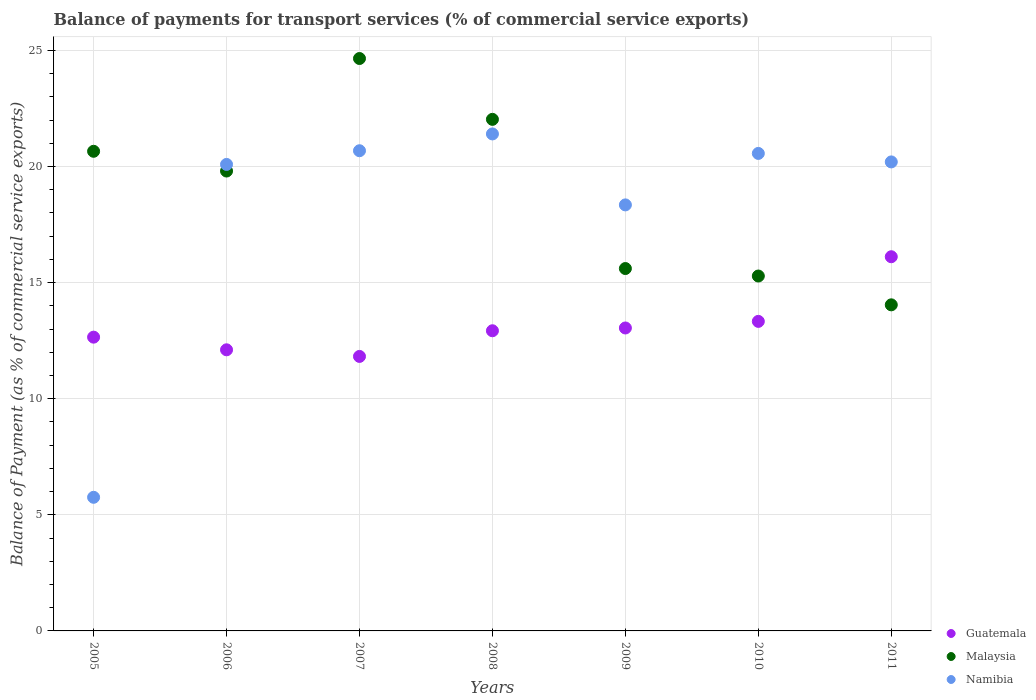Is the number of dotlines equal to the number of legend labels?
Your response must be concise. Yes. What is the balance of payments for transport services in Guatemala in 2011?
Provide a short and direct response. 16.11. Across all years, what is the maximum balance of payments for transport services in Guatemala?
Keep it short and to the point. 16.11. Across all years, what is the minimum balance of payments for transport services in Guatemala?
Give a very brief answer. 11.82. In which year was the balance of payments for transport services in Malaysia maximum?
Your answer should be very brief. 2007. What is the total balance of payments for transport services in Namibia in the graph?
Provide a short and direct response. 127.02. What is the difference between the balance of payments for transport services in Namibia in 2008 and that in 2010?
Your answer should be compact. 0.84. What is the difference between the balance of payments for transport services in Guatemala in 2006 and the balance of payments for transport services in Malaysia in 2005?
Offer a terse response. -8.55. What is the average balance of payments for transport services in Namibia per year?
Your response must be concise. 18.15. In the year 2011, what is the difference between the balance of payments for transport services in Malaysia and balance of payments for transport services in Namibia?
Your response must be concise. -6.15. What is the ratio of the balance of payments for transport services in Guatemala in 2005 to that in 2009?
Your answer should be very brief. 0.97. Is the balance of payments for transport services in Guatemala in 2006 less than that in 2009?
Give a very brief answer. Yes. Is the difference between the balance of payments for transport services in Malaysia in 2006 and 2011 greater than the difference between the balance of payments for transport services in Namibia in 2006 and 2011?
Ensure brevity in your answer.  Yes. What is the difference between the highest and the second highest balance of payments for transport services in Malaysia?
Make the answer very short. 2.62. What is the difference between the highest and the lowest balance of payments for transport services in Namibia?
Give a very brief answer. 15.65. In how many years, is the balance of payments for transport services in Guatemala greater than the average balance of payments for transport services in Guatemala taken over all years?
Your answer should be compact. 2. Is the sum of the balance of payments for transport services in Guatemala in 2007 and 2008 greater than the maximum balance of payments for transport services in Malaysia across all years?
Your answer should be very brief. Yes. Does the balance of payments for transport services in Guatemala monotonically increase over the years?
Make the answer very short. No. Is the balance of payments for transport services in Guatemala strictly less than the balance of payments for transport services in Namibia over the years?
Provide a succinct answer. No. How many dotlines are there?
Offer a terse response. 3. What is the difference between two consecutive major ticks on the Y-axis?
Make the answer very short. 5. Are the values on the major ticks of Y-axis written in scientific E-notation?
Make the answer very short. No. Does the graph contain any zero values?
Offer a terse response. No. How many legend labels are there?
Give a very brief answer. 3. What is the title of the graph?
Your answer should be very brief. Balance of payments for transport services (% of commercial service exports). What is the label or title of the X-axis?
Provide a succinct answer. Years. What is the label or title of the Y-axis?
Your answer should be compact. Balance of Payment (as % of commercial service exports). What is the Balance of Payment (as % of commercial service exports) in Guatemala in 2005?
Your response must be concise. 12.65. What is the Balance of Payment (as % of commercial service exports) of Malaysia in 2005?
Offer a very short reply. 20.65. What is the Balance of Payment (as % of commercial service exports) of Namibia in 2005?
Provide a short and direct response. 5.75. What is the Balance of Payment (as % of commercial service exports) in Guatemala in 2006?
Make the answer very short. 12.1. What is the Balance of Payment (as % of commercial service exports) in Malaysia in 2006?
Ensure brevity in your answer.  19.8. What is the Balance of Payment (as % of commercial service exports) of Namibia in 2006?
Offer a terse response. 20.09. What is the Balance of Payment (as % of commercial service exports) of Guatemala in 2007?
Provide a short and direct response. 11.82. What is the Balance of Payment (as % of commercial service exports) of Malaysia in 2007?
Provide a short and direct response. 24.65. What is the Balance of Payment (as % of commercial service exports) of Namibia in 2007?
Offer a terse response. 20.68. What is the Balance of Payment (as % of commercial service exports) in Guatemala in 2008?
Ensure brevity in your answer.  12.92. What is the Balance of Payment (as % of commercial service exports) of Malaysia in 2008?
Ensure brevity in your answer.  22.03. What is the Balance of Payment (as % of commercial service exports) of Namibia in 2008?
Make the answer very short. 21.4. What is the Balance of Payment (as % of commercial service exports) in Guatemala in 2009?
Offer a very short reply. 13.04. What is the Balance of Payment (as % of commercial service exports) of Malaysia in 2009?
Give a very brief answer. 15.6. What is the Balance of Payment (as % of commercial service exports) in Namibia in 2009?
Give a very brief answer. 18.34. What is the Balance of Payment (as % of commercial service exports) in Guatemala in 2010?
Offer a terse response. 13.33. What is the Balance of Payment (as % of commercial service exports) of Malaysia in 2010?
Provide a succinct answer. 15.28. What is the Balance of Payment (as % of commercial service exports) of Namibia in 2010?
Keep it short and to the point. 20.56. What is the Balance of Payment (as % of commercial service exports) of Guatemala in 2011?
Offer a terse response. 16.11. What is the Balance of Payment (as % of commercial service exports) in Malaysia in 2011?
Keep it short and to the point. 14.04. What is the Balance of Payment (as % of commercial service exports) of Namibia in 2011?
Your answer should be compact. 20.2. Across all years, what is the maximum Balance of Payment (as % of commercial service exports) of Guatemala?
Offer a terse response. 16.11. Across all years, what is the maximum Balance of Payment (as % of commercial service exports) of Malaysia?
Your response must be concise. 24.65. Across all years, what is the maximum Balance of Payment (as % of commercial service exports) of Namibia?
Provide a succinct answer. 21.4. Across all years, what is the minimum Balance of Payment (as % of commercial service exports) in Guatemala?
Your answer should be very brief. 11.82. Across all years, what is the minimum Balance of Payment (as % of commercial service exports) of Malaysia?
Offer a very short reply. 14.04. Across all years, what is the minimum Balance of Payment (as % of commercial service exports) in Namibia?
Provide a short and direct response. 5.75. What is the total Balance of Payment (as % of commercial service exports) of Guatemala in the graph?
Keep it short and to the point. 91.98. What is the total Balance of Payment (as % of commercial service exports) in Malaysia in the graph?
Ensure brevity in your answer.  132.06. What is the total Balance of Payment (as % of commercial service exports) in Namibia in the graph?
Provide a short and direct response. 127.02. What is the difference between the Balance of Payment (as % of commercial service exports) in Guatemala in 2005 and that in 2006?
Your answer should be very brief. 0.54. What is the difference between the Balance of Payment (as % of commercial service exports) of Malaysia in 2005 and that in 2006?
Give a very brief answer. 0.85. What is the difference between the Balance of Payment (as % of commercial service exports) in Namibia in 2005 and that in 2006?
Ensure brevity in your answer.  -14.33. What is the difference between the Balance of Payment (as % of commercial service exports) in Guatemala in 2005 and that in 2007?
Your response must be concise. 0.83. What is the difference between the Balance of Payment (as % of commercial service exports) of Malaysia in 2005 and that in 2007?
Provide a short and direct response. -4. What is the difference between the Balance of Payment (as % of commercial service exports) in Namibia in 2005 and that in 2007?
Make the answer very short. -14.92. What is the difference between the Balance of Payment (as % of commercial service exports) in Guatemala in 2005 and that in 2008?
Your answer should be compact. -0.28. What is the difference between the Balance of Payment (as % of commercial service exports) of Malaysia in 2005 and that in 2008?
Ensure brevity in your answer.  -1.38. What is the difference between the Balance of Payment (as % of commercial service exports) in Namibia in 2005 and that in 2008?
Your answer should be compact. -15.65. What is the difference between the Balance of Payment (as % of commercial service exports) in Guatemala in 2005 and that in 2009?
Offer a very short reply. -0.4. What is the difference between the Balance of Payment (as % of commercial service exports) of Malaysia in 2005 and that in 2009?
Make the answer very short. 5.05. What is the difference between the Balance of Payment (as % of commercial service exports) of Namibia in 2005 and that in 2009?
Offer a terse response. -12.59. What is the difference between the Balance of Payment (as % of commercial service exports) in Guatemala in 2005 and that in 2010?
Your answer should be compact. -0.68. What is the difference between the Balance of Payment (as % of commercial service exports) of Malaysia in 2005 and that in 2010?
Give a very brief answer. 5.37. What is the difference between the Balance of Payment (as % of commercial service exports) in Namibia in 2005 and that in 2010?
Your response must be concise. -14.81. What is the difference between the Balance of Payment (as % of commercial service exports) of Guatemala in 2005 and that in 2011?
Keep it short and to the point. -3.46. What is the difference between the Balance of Payment (as % of commercial service exports) of Malaysia in 2005 and that in 2011?
Provide a short and direct response. 6.61. What is the difference between the Balance of Payment (as % of commercial service exports) in Namibia in 2005 and that in 2011?
Offer a very short reply. -14.44. What is the difference between the Balance of Payment (as % of commercial service exports) in Guatemala in 2006 and that in 2007?
Provide a succinct answer. 0.28. What is the difference between the Balance of Payment (as % of commercial service exports) of Malaysia in 2006 and that in 2007?
Keep it short and to the point. -4.85. What is the difference between the Balance of Payment (as % of commercial service exports) of Namibia in 2006 and that in 2007?
Your answer should be compact. -0.59. What is the difference between the Balance of Payment (as % of commercial service exports) of Guatemala in 2006 and that in 2008?
Provide a short and direct response. -0.82. What is the difference between the Balance of Payment (as % of commercial service exports) in Malaysia in 2006 and that in 2008?
Offer a very short reply. -2.23. What is the difference between the Balance of Payment (as % of commercial service exports) in Namibia in 2006 and that in 2008?
Your answer should be very brief. -1.31. What is the difference between the Balance of Payment (as % of commercial service exports) of Guatemala in 2006 and that in 2009?
Your answer should be very brief. -0.94. What is the difference between the Balance of Payment (as % of commercial service exports) in Malaysia in 2006 and that in 2009?
Offer a terse response. 4.2. What is the difference between the Balance of Payment (as % of commercial service exports) in Namibia in 2006 and that in 2009?
Provide a short and direct response. 1.74. What is the difference between the Balance of Payment (as % of commercial service exports) of Guatemala in 2006 and that in 2010?
Provide a succinct answer. -1.22. What is the difference between the Balance of Payment (as % of commercial service exports) of Malaysia in 2006 and that in 2010?
Offer a terse response. 4.52. What is the difference between the Balance of Payment (as % of commercial service exports) of Namibia in 2006 and that in 2010?
Ensure brevity in your answer.  -0.47. What is the difference between the Balance of Payment (as % of commercial service exports) in Guatemala in 2006 and that in 2011?
Your response must be concise. -4.01. What is the difference between the Balance of Payment (as % of commercial service exports) of Malaysia in 2006 and that in 2011?
Your answer should be compact. 5.76. What is the difference between the Balance of Payment (as % of commercial service exports) of Namibia in 2006 and that in 2011?
Your answer should be very brief. -0.11. What is the difference between the Balance of Payment (as % of commercial service exports) of Guatemala in 2007 and that in 2008?
Ensure brevity in your answer.  -1.1. What is the difference between the Balance of Payment (as % of commercial service exports) of Malaysia in 2007 and that in 2008?
Provide a succinct answer. 2.62. What is the difference between the Balance of Payment (as % of commercial service exports) of Namibia in 2007 and that in 2008?
Ensure brevity in your answer.  -0.72. What is the difference between the Balance of Payment (as % of commercial service exports) of Guatemala in 2007 and that in 2009?
Ensure brevity in your answer.  -1.22. What is the difference between the Balance of Payment (as % of commercial service exports) in Malaysia in 2007 and that in 2009?
Your answer should be compact. 9.04. What is the difference between the Balance of Payment (as % of commercial service exports) of Namibia in 2007 and that in 2009?
Provide a short and direct response. 2.33. What is the difference between the Balance of Payment (as % of commercial service exports) of Guatemala in 2007 and that in 2010?
Offer a very short reply. -1.51. What is the difference between the Balance of Payment (as % of commercial service exports) of Malaysia in 2007 and that in 2010?
Your answer should be compact. 9.37. What is the difference between the Balance of Payment (as % of commercial service exports) of Namibia in 2007 and that in 2010?
Ensure brevity in your answer.  0.12. What is the difference between the Balance of Payment (as % of commercial service exports) of Guatemala in 2007 and that in 2011?
Give a very brief answer. -4.29. What is the difference between the Balance of Payment (as % of commercial service exports) in Malaysia in 2007 and that in 2011?
Provide a short and direct response. 10.61. What is the difference between the Balance of Payment (as % of commercial service exports) in Namibia in 2007 and that in 2011?
Provide a succinct answer. 0.48. What is the difference between the Balance of Payment (as % of commercial service exports) of Guatemala in 2008 and that in 2009?
Offer a terse response. -0.12. What is the difference between the Balance of Payment (as % of commercial service exports) of Malaysia in 2008 and that in 2009?
Ensure brevity in your answer.  6.42. What is the difference between the Balance of Payment (as % of commercial service exports) in Namibia in 2008 and that in 2009?
Your response must be concise. 3.06. What is the difference between the Balance of Payment (as % of commercial service exports) in Guatemala in 2008 and that in 2010?
Give a very brief answer. -0.4. What is the difference between the Balance of Payment (as % of commercial service exports) of Malaysia in 2008 and that in 2010?
Offer a terse response. 6.75. What is the difference between the Balance of Payment (as % of commercial service exports) of Namibia in 2008 and that in 2010?
Keep it short and to the point. 0.84. What is the difference between the Balance of Payment (as % of commercial service exports) in Guatemala in 2008 and that in 2011?
Keep it short and to the point. -3.19. What is the difference between the Balance of Payment (as % of commercial service exports) in Malaysia in 2008 and that in 2011?
Your answer should be compact. 7.99. What is the difference between the Balance of Payment (as % of commercial service exports) of Namibia in 2008 and that in 2011?
Provide a succinct answer. 1.2. What is the difference between the Balance of Payment (as % of commercial service exports) in Guatemala in 2009 and that in 2010?
Provide a short and direct response. -0.28. What is the difference between the Balance of Payment (as % of commercial service exports) of Malaysia in 2009 and that in 2010?
Your answer should be very brief. 0.32. What is the difference between the Balance of Payment (as % of commercial service exports) of Namibia in 2009 and that in 2010?
Your answer should be compact. -2.22. What is the difference between the Balance of Payment (as % of commercial service exports) in Guatemala in 2009 and that in 2011?
Give a very brief answer. -3.07. What is the difference between the Balance of Payment (as % of commercial service exports) in Malaysia in 2009 and that in 2011?
Your answer should be very brief. 1.56. What is the difference between the Balance of Payment (as % of commercial service exports) in Namibia in 2009 and that in 2011?
Offer a very short reply. -1.85. What is the difference between the Balance of Payment (as % of commercial service exports) of Guatemala in 2010 and that in 2011?
Offer a very short reply. -2.78. What is the difference between the Balance of Payment (as % of commercial service exports) of Malaysia in 2010 and that in 2011?
Your response must be concise. 1.24. What is the difference between the Balance of Payment (as % of commercial service exports) in Namibia in 2010 and that in 2011?
Provide a short and direct response. 0.37. What is the difference between the Balance of Payment (as % of commercial service exports) of Guatemala in 2005 and the Balance of Payment (as % of commercial service exports) of Malaysia in 2006?
Provide a short and direct response. -7.15. What is the difference between the Balance of Payment (as % of commercial service exports) in Guatemala in 2005 and the Balance of Payment (as % of commercial service exports) in Namibia in 2006?
Your response must be concise. -7.44. What is the difference between the Balance of Payment (as % of commercial service exports) of Malaysia in 2005 and the Balance of Payment (as % of commercial service exports) of Namibia in 2006?
Offer a very short reply. 0.57. What is the difference between the Balance of Payment (as % of commercial service exports) of Guatemala in 2005 and the Balance of Payment (as % of commercial service exports) of Malaysia in 2007?
Your response must be concise. -12. What is the difference between the Balance of Payment (as % of commercial service exports) in Guatemala in 2005 and the Balance of Payment (as % of commercial service exports) in Namibia in 2007?
Provide a succinct answer. -8.03. What is the difference between the Balance of Payment (as % of commercial service exports) in Malaysia in 2005 and the Balance of Payment (as % of commercial service exports) in Namibia in 2007?
Offer a terse response. -0.02. What is the difference between the Balance of Payment (as % of commercial service exports) of Guatemala in 2005 and the Balance of Payment (as % of commercial service exports) of Malaysia in 2008?
Provide a succinct answer. -9.38. What is the difference between the Balance of Payment (as % of commercial service exports) of Guatemala in 2005 and the Balance of Payment (as % of commercial service exports) of Namibia in 2008?
Provide a succinct answer. -8.75. What is the difference between the Balance of Payment (as % of commercial service exports) in Malaysia in 2005 and the Balance of Payment (as % of commercial service exports) in Namibia in 2008?
Keep it short and to the point. -0.75. What is the difference between the Balance of Payment (as % of commercial service exports) of Guatemala in 2005 and the Balance of Payment (as % of commercial service exports) of Malaysia in 2009?
Ensure brevity in your answer.  -2.95. What is the difference between the Balance of Payment (as % of commercial service exports) of Guatemala in 2005 and the Balance of Payment (as % of commercial service exports) of Namibia in 2009?
Give a very brief answer. -5.7. What is the difference between the Balance of Payment (as % of commercial service exports) of Malaysia in 2005 and the Balance of Payment (as % of commercial service exports) of Namibia in 2009?
Keep it short and to the point. 2.31. What is the difference between the Balance of Payment (as % of commercial service exports) of Guatemala in 2005 and the Balance of Payment (as % of commercial service exports) of Malaysia in 2010?
Offer a very short reply. -2.63. What is the difference between the Balance of Payment (as % of commercial service exports) of Guatemala in 2005 and the Balance of Payment (as % of commercial service exports) of Namibia in 2010?
Ensure brevity in your answer.  -7.91. What is the difference between the Balance of Payment (as % of commercial service exports) of Malaysia in 2005 and the Balance of Payment (as % of commercial service exports) of Namibia in 2010?
Keep it short and to the point. 0.09. What is the difference between the Balance of Payment (as % of commercial service exports) in Guatemala in 2005 and the Balance of Payment (as % of commercial service exports) in Malaysia in 2011?
Provide a succinct answer. -1.39. What is the difference between the Balance of Payment (as % of commercial service exports) of Guatemala in 2005 and the Balance of Payment (as % of commercial service exports) of Namibia in 2011?
Make the answer very short. -7.55. What is the difference between the Balance of Payment (as % of commercial service exports) of Malaysia in 2005 and the Balance of Payment (as % of commercial service exports) of Namibia in 2011?
Your answer should be compact. 0.46. What is the difference between the Balance of Payment (as % of commercial service exports) of Guatemala in 2006 and the Balance of Payment (as % of commercial service exports) of Malaysia in 2007?
Your response must be concise. -12.54. What is the difference between the Balance of Payment (as % of commercial service exports) of Guatemala in 2006 and the Balance of Payment (as % of commercial service exports) of Namibia in 2007?
Ensure brevity in your answer.  -8.57. What is the difference between the Balance of Payment (as % of commercial service exports) in Malaysia in 2006 and the Balance of Payment (as % of commercial service exports) in Namibia in 2007?
Your response must be concise. -0.87. What is the difference between the Balance of Payment (as % of commercial service exports) in Guatemala in 2006 and the Balance of Payment (as % of commercial service exports) in Malaysia in 2008?
Your answer should be compact. -9.92. What is the difference between the Balance of Payment (as % of commercial service exports) in Guatemala in 2006 and the Balance of Payment (as % of commercial service exports) in Namibia in 2008?
Provide a succinct answer. -9.3. What is the difference between the Balance of Payment (as % of commercial service exports) of Malaysia in 2006 and the Balance of Payment (as % of commercial service exports) of Namibia in 2008?
Give a very brief answer. -1.6. What is the difference between the Balance of Payment (as % of commercial service exports) of Guatemala in 2006 and the Balance of Payment (as % of commercial service exports) of Malaysia in 2009?
Provide a short and direct response. -3.5. What is the difference between the Balance of Payment (as % of commercial service exports) of Guatemala in 2006 and the Balance of Payment (as % of commercial service exports) of Namibia in 2009?
Provide a succinct answer. -6.24. What is the difference between the Balance of Payment (as % of commercial service exports) of Malaysia in 2006 and the Balance of Payment (as % of commercial service exports) of Namibia in 2009?
Your answer should be very brief. 1.46. What is the difference between the Balance of Payment (as % of commercial service exports) in Guatemala in 2006 and the Balance of Payment (as % of commercial service exports) in Malaysia in 2010?
Offer a terse response. -3.18. What is the difference between the Balance of Payment (as % of commercial service exports) in Guatemala in 2006 and the Balance of Payment (as % of commercial service exports) in Namibia in 2010?
Your response must be concise. -8.46. What is the difference between the Balance of Payment (as % of commercial service exports) of Malaysia in 2006 and the Balance of Payment (as % of commercial service exports) of Namibia in 2010?
Provide a short and direct response. -0.76. What is the difference between the Balance of Payment (as % of commercial service exports) of Guatemala in 2006 and the Balance of Payment (as % of commercial service exports) of Malaysia in 2011?
Your answer should be compact. -1.94. What is the difference between the Balance of Payment (as % of commercial service exports) in Guatemala in 2006 and the Balance of Payment (as % of commercial service exports) in Namibia in 2011?
Give a very brief answer. -8.09. What is the difference between the Balance of Payment (as % of commercial service exports) of Malaysia in 2006 and the Balance of Payment (as % of commercial service exports) of Namibia in 2011?
Provide a succinct answer. -0.39. What is the difference between the Balance of Payment (as % of commercial service exports) in Guatemala in 2007 and the Balance of Payment (as % of commercial service exports) in Malaysia in 2008?
Ensure brevity in your answer.  -10.21. What is the difference between the Balance of Payment (as % of commercial service exports) in Guatemala in 2007 and the Balance of Payment (as % of commercial service exports) in Namibia in 2008?
Your response must be concise. -9.58. What is the difference between the Balance of Payment (as % of commercial service exports) of Malaysia in 2007 and the Balance of Payment (as % of commercial service exports) of Namibia in 2008?
Offer a very short reply. 3.25. What is the difference between the Balance of Payment (as % of commercial service exports) of Guatemala in 2007 and the Balance of Payment (as % of commercial service exports) of Malaysia in 2009?
Your answer should be very brief. -3.78. What is the difference between the Balance of Payment (as % of commercial service exports) of Guatemala in 2007 and the Balance of Payment (as % of commercial service exports) of Namibia in 2009?
Ensure brevity in your answer.  -6.52. What is the difference between the Balance of Payment (as % of commercial service exports) of Malaysia in 2007 and the Balance of Payment (as % of commercial service exports) of Namibia in 2009?
Provide a short and direct response. 6.3. What is the difference between the Balance of Payment (as % of commercial service exports) of Guatemala in 2007 and the Balance of Payment (as % of commercial service exports) of Malaysia in 2010?
Give a very brief answer. -3.46. What is the difference between the Balance of Payment (as % of commercial service exports) in Guatemala in 2007 and the Balance of Payment (as % of commercial service exports) in Namibia in 2010?
Offer a very short reply. -8.74. What is the difference between the Balance of Payment (as % of commercial service exports) of Malaysia in 2007 and the Balance of Payment (as % of commercial service exports) of Namibia in 2010?
Your answer should be compact. 4.09. What is the difference between the Balance of Payment (as % of commercial service exports) in Guatemala in 2007 and the Balance of Payment (as % of commercial service exports) in Malaysia in 2011?
Make the answer very short. -2.22. What is the difference between the Balance of Payment (as % of commercial service exports) in Guatemala in 2007 and the Balance of Payment (as % of commercial service exports) in Namibia in 2011?
Your answer should be compact. -8.38. What is the difference between the Balance of Payment (as % of commercial service exports) of Malaysia in 2007 and the Balance of Payment (as % of commercial service exports) of Namibia in 2011?
Your response must be concise. 4.45. What is the difference between the Balance of Payment (as % of commercial service exports) in Guatemala in 2008 and the Balance of Payment (as % of commercial service exports) in Malaysia in 2009?
Ensure brevity in your answer.  -2.68. What is the difference between the Balance of Payment (as % of commercial service exports) in Guatemala in 2008 and the Balance of Payment (as % of commercial service exports) in Namibia in 2009?
Keep it short and to the point. -5.42. What is the difference between the Balance of Payment (as % of commercial service exports) in Malaysia in 2008 and the Balance of Payment (as % of commercial service exports) in Namibia in 2009?
Provide a short and direct response. 3.68. What is the difference between the Balance of Payment (as % of commercial service exports) of Guatemala in 2008 and the Balance of Payment (as % of commercial service exports) of Malaysia in 2010?
Offer a very short reply. -2.36. What is the difference between the Balance of Payment (as % of commercial service exports) of Guatemala in 2008 and the Balance of Payment (as % of commercial service exports) of Namibia in 2010?
Your answer should be compact. -7.64. What is the difference between the Balance of Payment (as % of commercial service exports) of Malaysia in 2008 and the Balance of Payment (as % of commercial service exports) of Namibia in 2010?
Offer a very short reply. 1.47. What is the difference between the Balance of Payment (as % of commercial service exports) of Guatemala in 2008 and the Balance of Payment (as % of commercial service exports) of Malaysia in 2011?
Your response must be concise. -1.12. What is the difference between the Balance of Payment (as % of commercial service exports) in Guatemala in 2008 and the Balance of Payment (as % of commercial service exports) in Namibia in 2011?
Provide a short and direct response. -7.27. What is the difference between the Balance of Payment (as % of commercial service exports) of Malaysia in 2008 and the Balance of Payment (as % of commercial service exports) of Namibia in 2011?
Offer a very short reply. 1.83. What is the difference between the Balance of Payment (as % of commercial service exports) in Guatemala in 2009 and the Balance of Payment (as % of commercial service exports) in Malaysia in 2010?
Provide a short and direct response. -2.24. What is the difference between the Balance of Payment (as % of commercial service exports) of Guatemala in 2009 and the Balance of Payment (as % of commercial service exports) of Namibia in 2010?
Offer a terse response. -7.52. What is the difference between the Balance of Payment (as % of commercial service exports) in Malaysia in 2009 and the Balance of Payment (as % of commercial service exports) in Namibia in 2010?
Provide a succinct answer. -4.96. What is the difference between the Balance of Payment (as % of commercial service exports) of Guatemala in 2009 and the Balance of Payment (as % of commercial service exports) of Malaysia in 2011?
Keep it short and to the point. -1. What is the difference between the Balance of Payment (as % of commercial service exports) of Guatemala in 2009 and the Balance of Payment (as % of commercial service exports) of Namibia in 2011?
Keep it short and to the point. -7.15. What is the difference between the Balance of Payment (as % of commercial service exports) in Malaysia in 2009 and the Balance of Payment (as % of commercial service exports) in Namibia in 2011?
Provide a succinct answer. -4.59. What is the difference between the Balance of Payment (as % of commercial service exports) of Guatemala in 2010 and the Balance of Payment (as % of commercial service exports) of Malaysia in 2011?
Give a very brief answer. -0.71. What is the difference between the Balance of Payment (as % of commercial service exports) in Guatemala in 2010 and the Balance of Payment (as % of commercial service exports) in Namibia in 2011?
Keep it short and to the point. -6.87. What is the difference between the Balance of Payment (as % of commercial service exports) in Malaysia in 2010 and the Balance of Payment (as % of commercial service exports) in Namibia in 2011?
Offer a very short reply. -4.91. What is the average Balance of Payment (as % of commercial service exports) of Guatemala per year?
Provide a succinct answer. 13.14. What is the average Balance of Payment (as % of commercial service exports) of Malaysia per year?
Your answer should be very brief. 18.87. What is the average Balance of Payment (as % of commercial service exports) of Namibia per year?
Your answer should be very brief. 18.15. In the year 2005, what is the difference between the Balance of Payment (as % of commercial service exports) in Guatemala and Balance of Payment (as % of commercial service exports) in Malaysia?
Offer a very short reply. -8. In the year 2005, what is the difference between the Balance of Payment (as % of commercial service exports) in Guatemala and Balance of Payment (as % of commercial service exports) in Namibia?
Your answer should be very brief. 6.9. In the year 2005, what is the difference between the Balance of Payment (as % of commercial service exports) in Malaysia and Balance of Payment (as % of commercial service exports) in Namibia?
Offer a terse response. 14.9. In the year 2006, what is the difference between the Balance of Payment (as % of commercial service exports) of Guatemala and Balance of Payment (as % of commercial service exports) of Malaysia?
Offer a very short reply. -7.7. In the year 2006, what is the difference between the Balance of Payment (as % of commercial service exports) of Guatemala and Balance of Payment (as % of commercial service exports) of Namibia?
Make the answer very short. -7.98. In the year 2006, what is the difference between the Balance of Payment (as % of commercial service exports) in Malaysia and Balance of Payment (as % of commercial service exports) in Namibia?
Provide a succinct answer. -0.28. In the year 2007, what is the difference between the Balance of Payment (as % of commercial service exports) in Guatemala and Balance of Payment (as % of commercial service exports) in Malaysia?
Keep it short and to the point. -12.83. In the year 2007, what is the difference between the Balance of Payment (as % of commercial service exports) in Guatemala and Balance of Payment (as % of commercial service exports) in Namibia?
Give a very brief answer. -8.86. In the year 2007, what is the difference between the Balance of Payment (as % of commercial service exports) in Malaysia and Balance of Payment (as % of commercial service exports) in Namibia?
Provide a short and direct response. 3.97. In the year 2008, what is the difference between the Balance of Payment (as % of commercial service exports) in Guatemala and Balance of Payment (as % of commercial service exports) in Malaysia?
Keep it short and to the point. -9.1. In the year 2008, what is the difference between the Balance of Payment (as % of commercial service exports) in Guatemala and Balance of Payment (as % of commercial service exports) in Namibia?
Your response must be concise. -8.48. In the year 2008, what is the difference between the Balance of Payment (as % of commercial service exports) in Malaysia and Balance of Payment (as % of commercial service exports) in Namibia?
Keep it short and to the point. 0.63. In the year 2009, what is the difference between the Balance of Payment (as % of commercial service exports) of Guatemala and Balance of Payment (as % of commercial service exports) of Malaysia?
Ensure brevity in your answer.  -2.56. In the year 2009, what is the difference between the Balance of Payment (as % of commercial service exports) of Guatemala and Balance of Payment (as % of commercial service exports) of Namibia?
Your response must be concise. -5.3. In the year 2009, what is the difference between the Balance of Payment (as % of commercial service exports) of Malaysia and Balance of Payment (as % of commercial service exports) of Namibia?
Give a very brief answer. -2.74. In the year 2010, what is the difference between the Balance of Payment (as % of commercial service exports) of Guatemala and Balance of Payment (as % of commercial service exports) of Malaysia?
Ensure brevity in your answer.  -1.95. In the year 2010, what is the difference between the Balance of Payment (as % of commercial service exports) in Guatemala and Balance of Payment (as % of commercial service exports) in Namibia?
Make the answer very short. -7.23. In the year 2010, what is the difference between the Balance of Payment (as % of commercial service exports) of Malaysia and Balance of Payment (as % of commercial service exports) of Namibia?
Your answer should be compact. -5.28. In the year 2011, what is the difference between the Balance of Payment (as % of commercial service exports) in Guatemala and Balance of Payment (as % of commercial service exports) in Malaysia?
Ensure brevity in your answer.  2.07. In the year 2011, what is the difference between the Balance of Payment (as % of commercial service exports) in Guatemala and Balance of Payment (as % of commercial service exports) in Namibia?
Your response must be concise. -4.08. In the year 2011, what is the difference between the Balance of Payment (as % of commercial service exports) in Malaysia and Balance of Payment (as % of commercial service exports) in Namibia?
Your answer should be compact. -6.15. What is the ratio of the Balance of Payment (as % of commercial service exports) in Guatemala in 2005 to that in 2006?
Your response must be concise. 1.04. What is the ratio of the Balance of Payment (as % of commercial service exports) of Malaysia in 2005 to that in 2006?
Offer a terse response. 1.04. What is the ratio of the Balance of Payment (as % of commercial service exports) of Namibia in 2005 to that in 2006?
Ensure brevity in your answer.  0.29. What is the ratio of the Balance of Payment (as % of commercial service exports) of Guatemala in 2005 to that in 2007?
Your answer should be compact. 1.07. What is the ratio of the Balance of Payment (as % of commercial service exports) of Malaysia in 2005 to that in 2007?
Provide a short and direct response. 0.84. What is the ratio of the Balance of Payment (as % of commercial service exports) of Namibia in 2005 to that in 2007?
Make the answer very short. 0.28. What is the ratio of the Balance of Payment (as % of commercial service exports) in Guatemala in 2005 to that in 2008?
Offer a terse response. 0.98. What is the ratio of the Balance of Payment (as % of commercial service exports) of Malaysia in 2005 to that in 2008?
Offer a very short reply. 0.94. What is the ratio of the Balance of Payment (as % of commercial service exports) of Namibia in 2005 to that in 2008?
Your answer should be compact. 0.27. What is the ratio of the Balance of Payment (as % of commercial service exports) of Guatemala in 2005 to that in 2009?
Offer a very short reply. 0.97. What is the ratio of the Balance of Payment (as % of commercial service exports) of Malaysia in 2005 to that in 2009?
Ensure brevity in your answer.  1.32. What is the ratio of the Balance of Payment (as % of commercial service exports) in Namibia in 2005 to that in 2009?
Provide a short and direct response. 0.31. What is the ratio of the Balance of Payment (as % of commercial service exports) of Guatemala in 2005 to that in 2010?
Offer a terse response. 0.95. What is the ratio of the Balance of Payment (as % of commercial service exports) in Malaysia in 2005 to that in 2010?
Your answer should be very brief. 1.35. What is the ratio of the Balance of Payment (as % of commercial service exports) in Namibia in 2005 to that in 2010?
Your answer should be compact. 0.28. What is the ratio of the Balance of Payment (as % of commercial service exports) in Guatemala in 2005 to that in 2011?
Ensure brevity in your answer.  0.79. What is the ratio of the Balance of Payment (as % of commercial service exports) in Malaysia in 2005 to that in 2011?
Offer a terse response. 1.47. What is the ratio of the Balance of Payment (as % of commercial service exports) in Namibia in 2005 to that in 2011?
Your answer should be compact. 0.28. What is the ratio of the Balance of Payment (as % of commercial service exports) in Guatemala in 2006 to that in 2007?
Offer a very short reply. 1.02. What is the ratio of the Balance of Payment (as % of commercial service exports) of Malaysia in 2006 to that in 2007?
Make the answer very short. 0.8. What is the ratio of the Balance of Payment (as % of commercial service exports) of Namibia in 2006 to that in 2007?
Your answer should be very brief. 0.97. What is the ratio of the Balance of Payment (as % of commercial service exports) in Guatemala in 2006 to that in 2008?
Provide a short and direct response. 0.94. What is the ratio of the Balance of Payment (as % of commercial service exports) of Malaysia in 2006 to that in 2008?
Your response must be concise. 0.9. What is the ratio of the Balance of Payment (as % of commercial service exports) of Namibia in 2006 to that in 2008?
Give a very brief answer. 0.94. What is the ratio of the Balance of Payment (as % of commercial service exports) in Guatemala in 2006 to that in 2009?
Give a very brief answer. 0.93. What is the ratio of the Balance of Payment (as % of commercial service exports) of Malaysia in 2006 to that in 2009?
Ensure brevity in your answer.  1.27. What is the ratio of the Balance of Payment (as % of commercial service exports) in Namibia in 2006 to that in 2009?
Your answer should be very brief. 1.09. What is the ratio of the Balance of Payment (as % of commercial service exports) of Guatemala in 2006 to that in 2010?
Offer a terse response. 0.91. What is the ratio of the Balance of Payment (as % of commercial service exports) of Malaysia in 2006 to that in 2010?
Provide a short and direct response. 1.3. What is the ratio of the Balance of Payment (as % of commercial service exports) of Namibia in 2006 to that in 2010?
Your answer should be compact. 0.98. What is the ratio of the Balance of Payment (as % of commercial service exports) in Guatemala in 2006 to that in 2011?
Offer a very short reply. 0.75. What is the ratio of the Balance of Payment (as % of commercial service exports) of Malaysia in 2006 to that in 2011?
Keep it short and to the point. 1.41. What is the ratio of the Balance of Payment (as % of commercial service exports) in Guatemala in 2007 to that in 2008?
Give a very brief answer. 0.91. What is the ratio of the Balance of Payment (as % of commercial service exports) in Malaysia in 2007 to that in 2008?
Your answer should be very brief. 1.12. What is the ratio of the Balance of Payment (as % of commercial service exports) in Namibia in 2007 to that in 2008?
Your answer should be very brief. 0.97. What is the ratio of the Balance of Payment (as % of commercial service exports) in Guatemala in 2007 to that in 2009?
Provide a succinct answer. 0.91. What is the ratio of the Balance of Payment (as % of commercial service exports) in Malaysia in 2007 to that in 2009?
Provide a short and direct response. 1.58. What is the ratio of the Balance of Payment (as % of commercial service exports) of Namibia in 2007 to that in 2009?
Offer a very short reply. 1.13. What is the ratio of the Balance of Payment (as % of commercial service exports) in Guatemala in 2007 to that in 2010?
Ensure brevity in your answer.  0.89. What is the ratio of the Balance of Payment (as % of commercial service exports) in Malaysia in 2007 to that in 2010?
Provide a succinct answer. 1.61. What is the ratio of the Balance of Payment (as % of commercial service exports) in Namibia in 2007 to that in 2010?
Provide a succinct answer. 1.01. What is the ratio of the Balance of Payment (as % of commercial service exports) in Guatemala in 2007 to that in 2011?
Make the answer very short. 0.73. What is the ratio of the Balance of Payment (as % of commercial service exports) in Malaysia in 2007 to that in 2011?
Give a very brief answer. 1.76. What is the ratio of the Balance of Payment (as % of commercial service exports) of Namibia in 2007 to that in 2011?
Offer a very short reply. 1.02. What is the ratio of the Balance of Payment (as % of commercial service exports) of Malaysia in 2008 to that in 2009?
Ensure brevity in your answer.  1.41. What is the ratio of the Balance of Payment (as % of commercial service exports) of Namibia in 2008 to that in 2009?
Your answer should be compact. 1.17. What is the ratio of the Balance of Payment (as % of commercial service exports) in Guatemala in 2008 to that in 2010?
Your answer should be very brief. 0.97. What is the ratio of the Balance of Payment (as % of commercial service exports) of Malaysia in 2008 to that in 2010?
Your answer should be compact. 1.44. What is the ratio of the Balance of Payment (as % of commercial service exports) in Namibia in 2008 to that in 2010?
Your answer should be very brief. 1.04. What is the ratio of the Balance of Payment (as % of commercial service exports) of Guatemala in 2008 to that in 2011?
Keep it short and to the point. 0.8. What is the ratio of the Balance of Payment (as % of commercial service exports) in Malaysia in 2008 to that in 2011?
Your answer should be compact. 1.57. What is the ratio of the Balance of Payment (as % of commercial service exports) in Namibia in 2008 to that in 2011?
Your response must be concise. 1.06. What is the ratio of the Balance of Payment (as % of commercial service exports) of Guatemala in 2009 to that in 2010?
Give a very brief answer. 0.98. What is the ratio of the Balance of Payment (as % of commercial service exports) of Malaysia in 2009 to that in 2010?
Offer a very short reply. 1.02. What is the ratio of the Balance of Payment (as % of commercial service exports) of Namibia in 2009 to that in 2010?
Make the answer very short. 0.89. What is the ratio of the Balance of Payment (as % of commercial service exports) of Guatemala in 2009 to that in 2011?
Offer a very short reply. 0.81. What is the ratio of the Balance of Payment (as % of commercial service exports) in Malaysia in 2009 to that in 2011?
Provide a succinct answer. 1.11. What is the ratio of the Balance of Payment (as % of commercial service exports) in Namibia in 2009 to that in 2011?
Offer a terse response. 0.91. What is the ratio of the Balance of Payment (as % of commercial service exports) in Guatemala in 2010 to that in 2011?
Offer a very short reply. 0.83. What is the ratio of the Balance of Payment (as % of commercial service exports) of Malaysia in 2010 to that in 2011?
Give a very brief answer. 1.09. What is the ratio of the Balance of Payment (as % of commercial service exports) in Namibia in 2010 to that in 2011?
Your answer should be compact. 1.02. What is the difference between the highest and the second highest Balance of Payment (as % of commercial service exports) of Guatemala?
Provide a short and direct response. 2.78. What is the difference between the highest and the second highest Balance of Payment (as % of commercial service exports) of Malaysia?
Offer a very short reply. 2.62. What is the difference between the highest and the second highest Balance of Payment (as % of commercial service exports) in Namibia?
Offer a very short reply. 0.72. What is the difference between the highest and the lowest Balance of Payment (as % of commercial service exports) in Guatemala?
Ensure brevity in your answer.  4.29. What is the difference between the highest and the lowest Balance of Payment (as % of commercial service exports) of Malaysia?
Provide a succinct answer. 10.61. What is the difference between the highest and the lowest Balance of Payment (as % of commercial service exports) in Namibia?
Offer a very short reply. 15.65. 